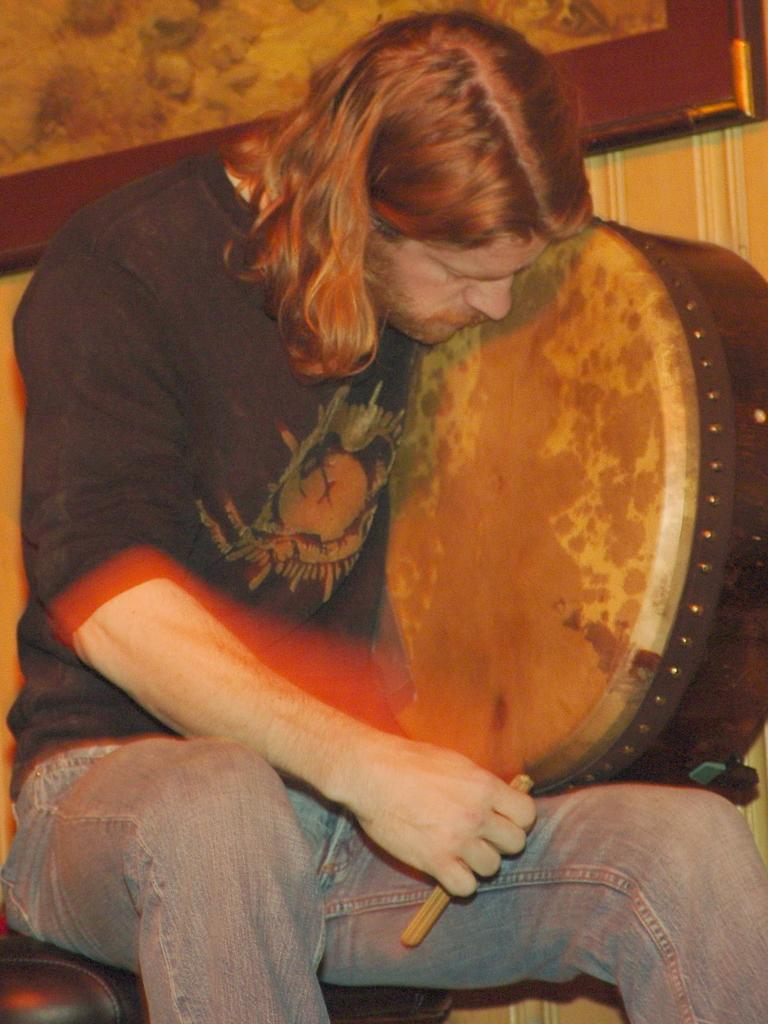What is the main subject of the image? There is a man sitting in the image. What is the man doing in the image? The man is sitting. What is the man holding in his hand? The man is holding something in his hand, but the specific object is not mentioned in the facts. What type of gun is the man holding in the image? There is no mention of a gun in the image or the facts provided. 